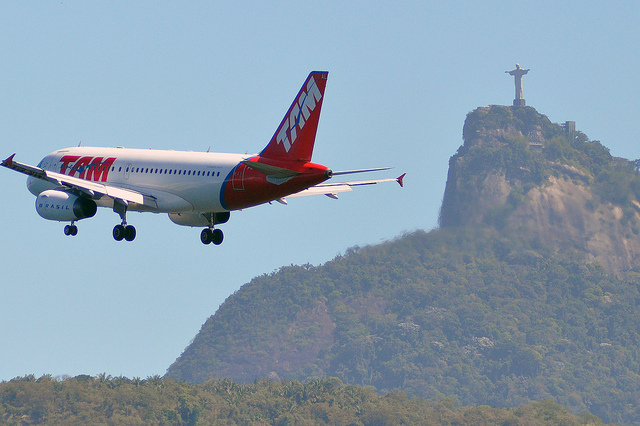What time of day does the image seem to depict? The image appears to depict daytime, evidenced by the clear and bright sky. The lighting suggests either late morning or early afternoon, where the sun's position provides ample illumination without casting long shadows. What are some possible destinations of the airplane based on its current flight path? Given the airplane's current flight path and its proximity to prominent landmarks like Christ the Redeemer, possible destinations could include major airports in Rio de Janeiro such as Rio de Janeiro-Galeão International Airport or Santos Dumont Airport. These airports serve as key hubs for both domestic and international flights, connecting Rio de Janeiro with various cities across Brazil and the world. Describe an imaginary advertisement using this image to promote tourism in Rio de Janeiro. Imagine an advertisement with the caption 'Discover the Heart of Brazil.' The visually striking image of the airplane flying near the Christ the Redeemer statue would be the focal point, symbolizing easy access to the wonders of Rio de Janeiro. The text would read: 'Fly to Rio and embark on an unforgettable journey. Experience the cultural vibrancy, stunning landscapes, and world-famous landmarks that make this city a jewel of Brazil. Start your adventure with a breathtaking aerial view, and let Rio de Janeiro welcome you with open arms.' This narrative would invite travelers to explore the rich heritage and scenic beauty of the city, making it an enticing destination for their next vacation. If you could add a fantastical element to the image, what would it be and how would it change the image's interpretation? If a fantastical element were added to the image, such as a giant, ethereal dragon soaring alongside the airplane, it would transform the image into a scene straight out of a fantasy novel. The dragon, depicted with shimmering scales and vibrant colors, would evoke a sense of wonder and magic. This addition would reinterpret the image from a realistic scene into a whimsical, imaginative narrative, where mythical creatures exist harmoniously with modern technology, inspiring a sense of adventure and storytelling. 